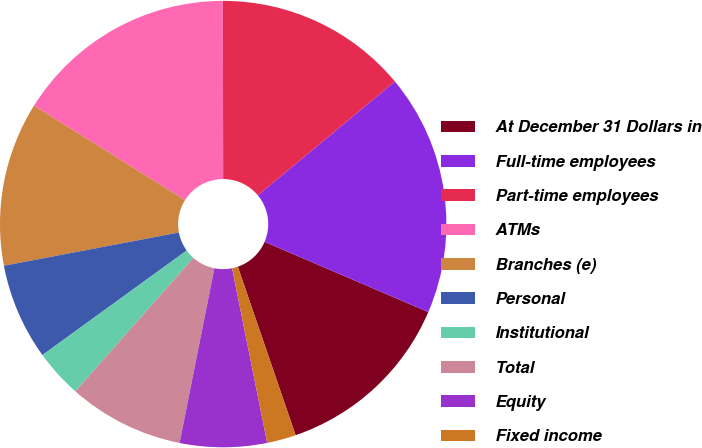Convert chart to OTSL. <chart><loc_0><loc_0><loc_500><loc_500><pie_chart><fcel>At December 31 Dollars in<fcel>Full-time employees<fcel>Part-time employees<fcel>ATMs<fcel>Branches (e)<fcel>Personal<fcel>Institutional<fcel>Total<fcel>Equity<fcel>Fixed income<nl><fcel>13.29%<fcel>17.48%<fcel>13.99%<fcel>16.08%<fcel>11.89%<fcel>6.99%<fcel>3.5%<fcel>8.39%<fcel>6.29%<fcel>2.1%<nl></chart> 